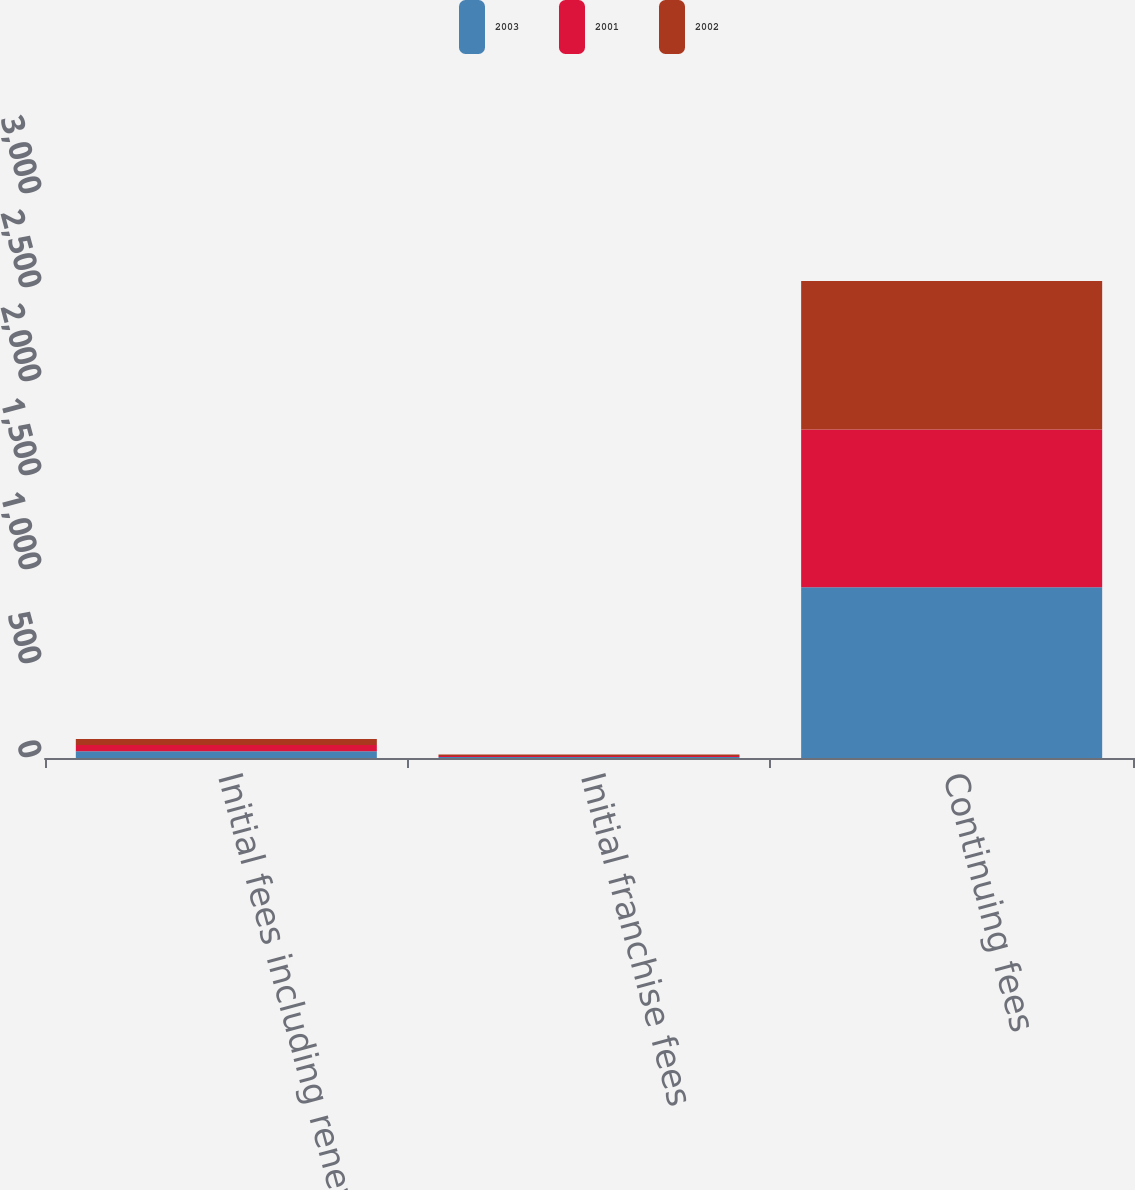Convert chart. <chart><loc_0><loc_0><loc_500><loc_500><stacked_bar_chart><ecel><fcel>Initial fees including renewal<fcel>Initial franchise fees<fcel>Continuing fees<nl><fcel>2003<fcel>36<fcel>5<fcel>908<nl><fcel>2001<fcel>33<fcel>6<fcel>839<nl><fcel>2002<fcel>32<fcel>7<fcel>790<nl></chart> 